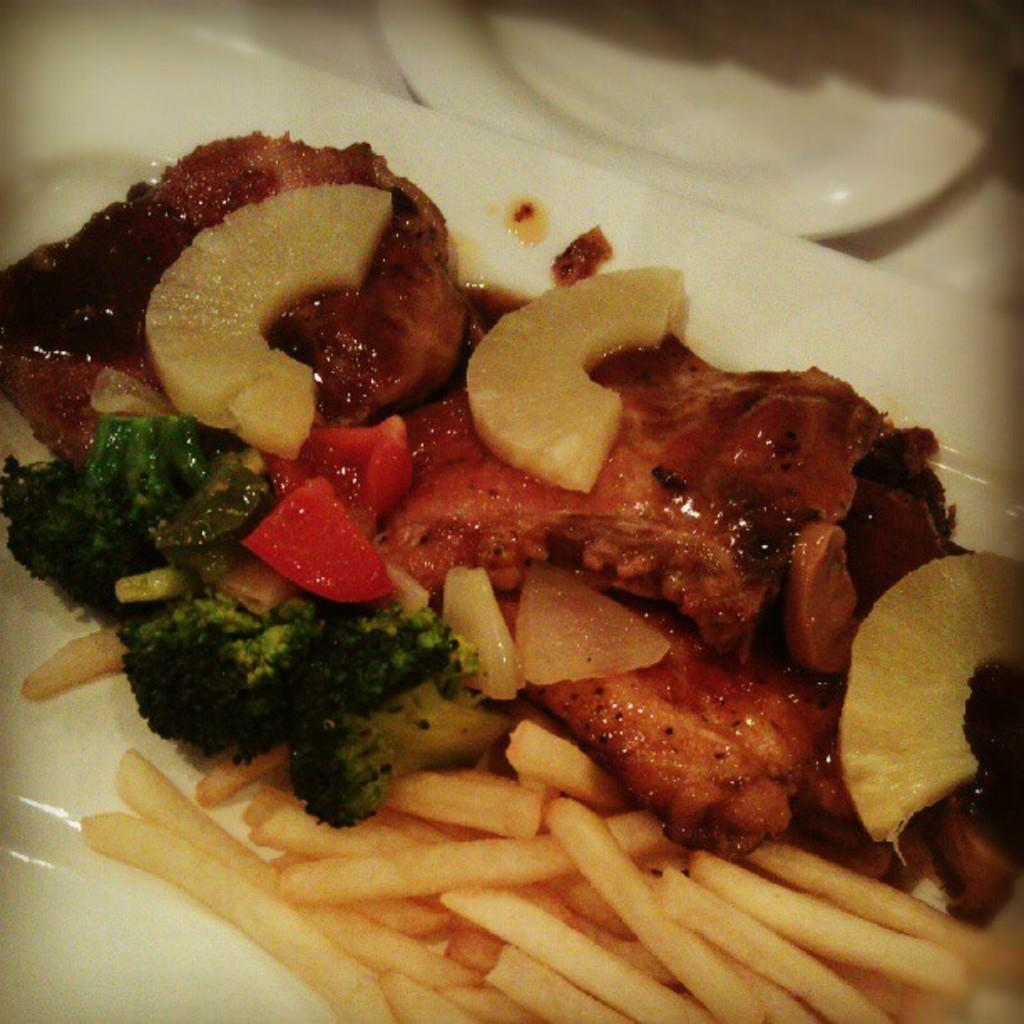What type of food can be seen in the image? The image contains food, including french fries, broccoli, and flesh (possibly meat). Can you describe the color of the plate containing the food? The plate containing the food is white. Are there any other plates visible in the image? Yes, there is another plate visible at the top of the image. What is the texture of the zinc in the image? There is no zinc present in the image, so it is not possible to determine its texture. 